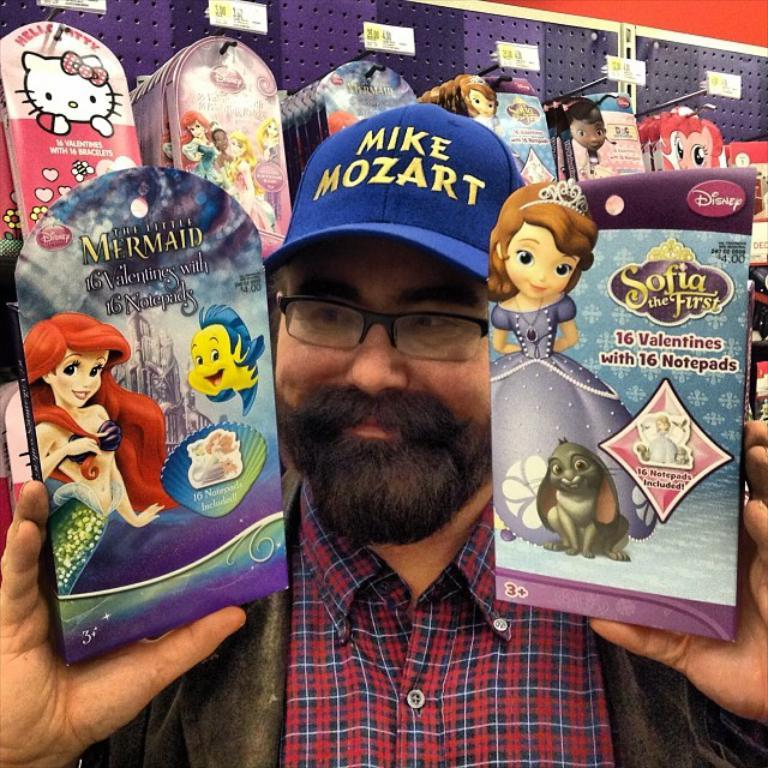What is the main subject of the image? There is a man standing in the middle of the image. What is the man holding in the image? The man is holding two notepads. What can be seen in the background of the image? There is a rack visible in the image. What is the purpose of the rack in the image? The rack contains notepads. What type of brush is the man using to control the notepads in the image? There is no brush present in the image, and the man is not controlling the notepads. 